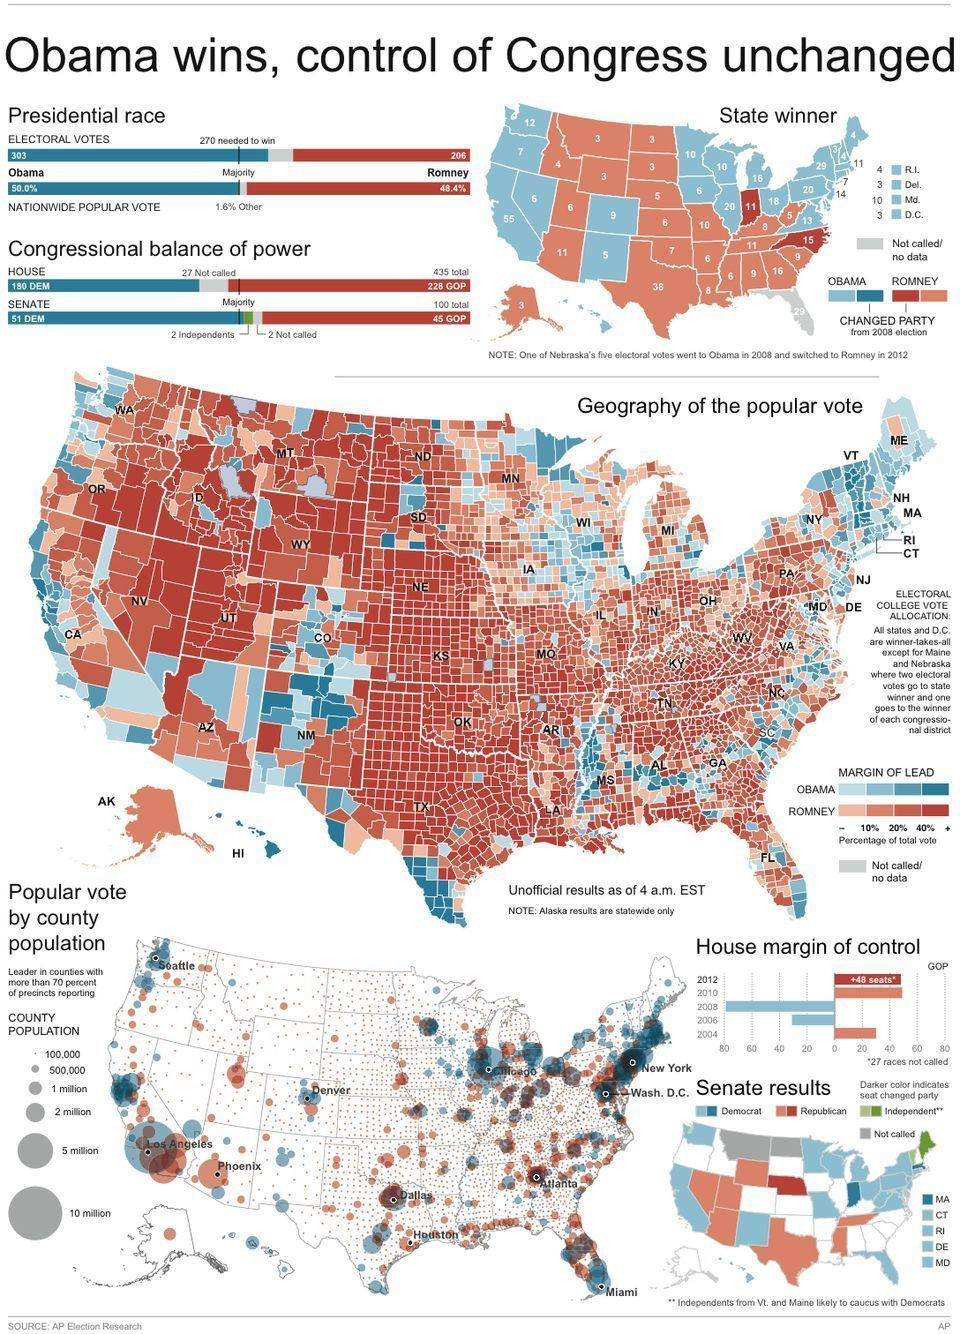What is difference in percentage of nationwide popular vote of Obama and Romney?
Answer the question with a short phrase. 1.6% Which party is represented by the green color, Republic, Independent or Democrat? Independent Which color represents the Republican party red, blue, green? red What was the difference in electoral votes of Obama and Romney ? 97 